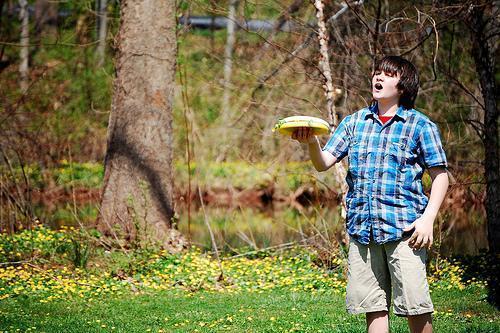How many people are shown?
Give a very brief answer. 1. 